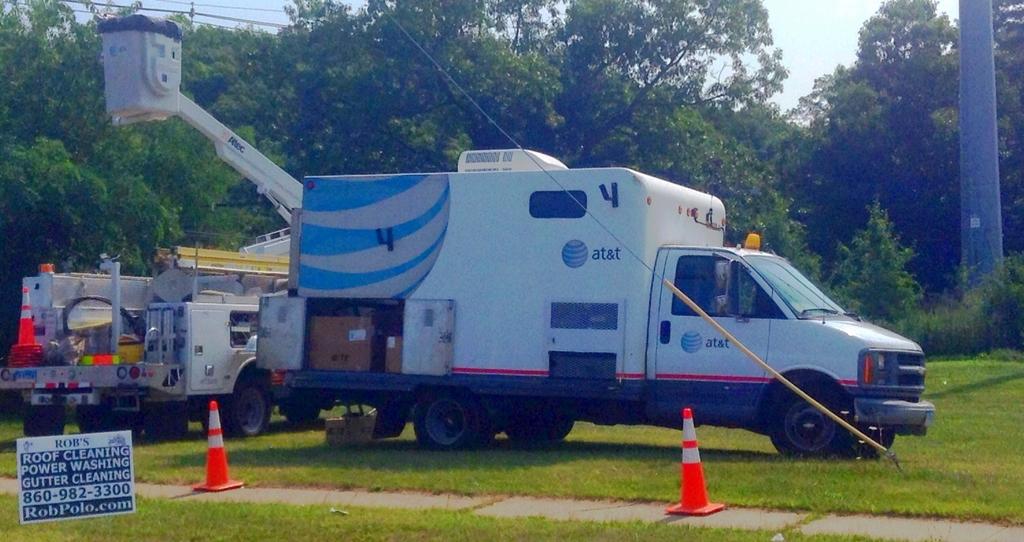Which carrier is this service vehicle for?
Your response must be concise. At&t. What's the phone number on the sign?
Your answer should be very brief. 860-982-3300. 